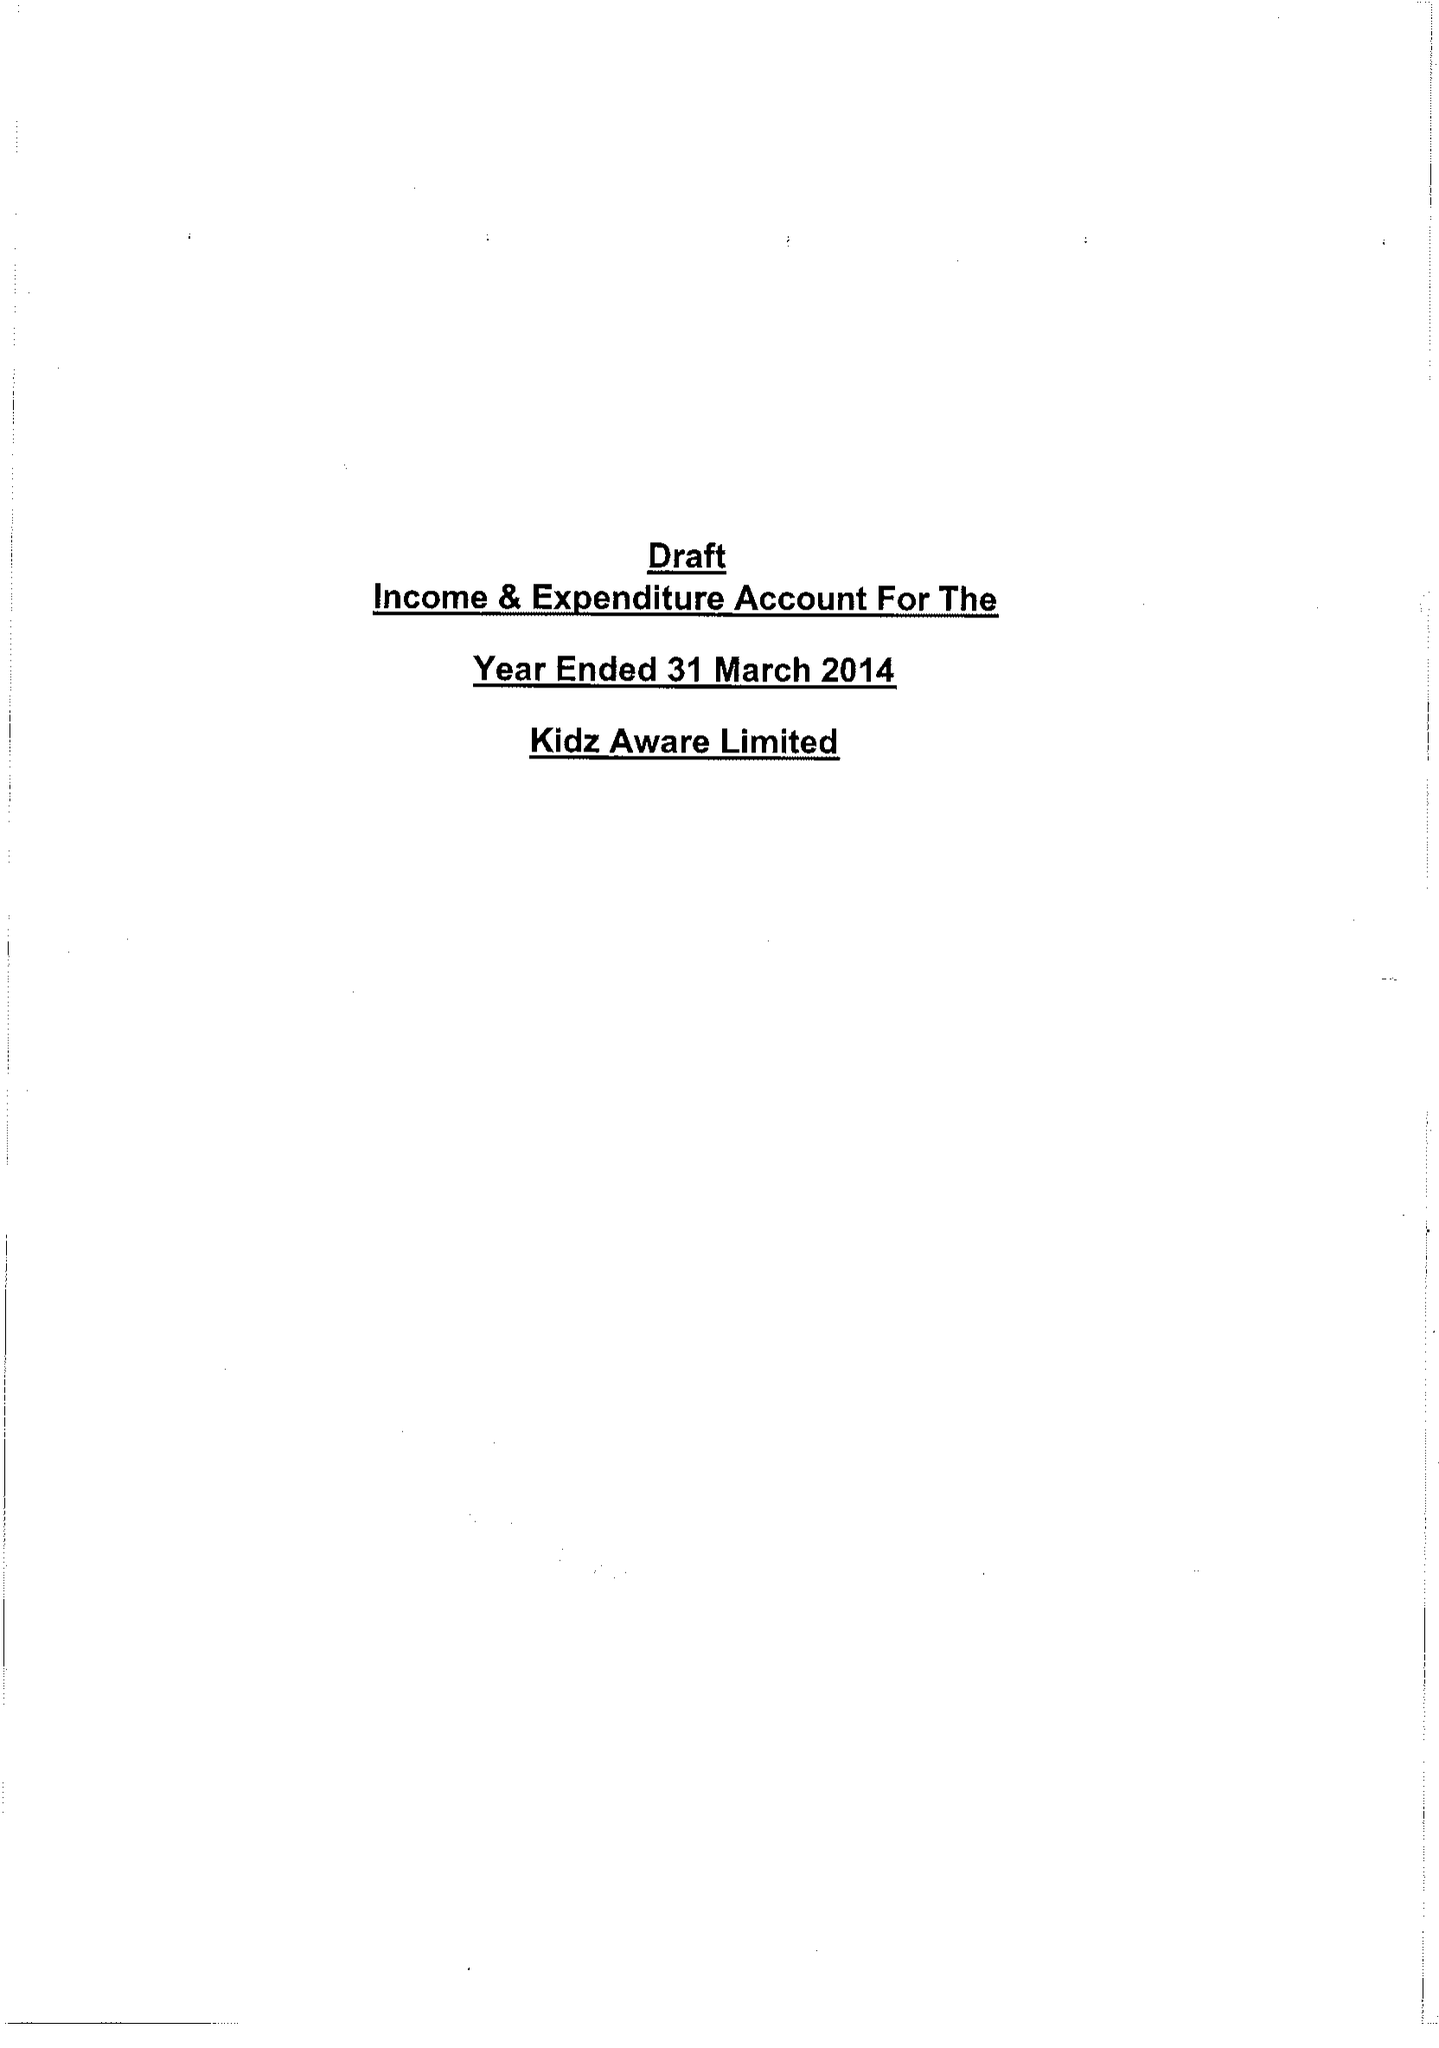What is the value for the charity_name?
Answer the question using a single word or phrase. Kidz Aware Ltd. 